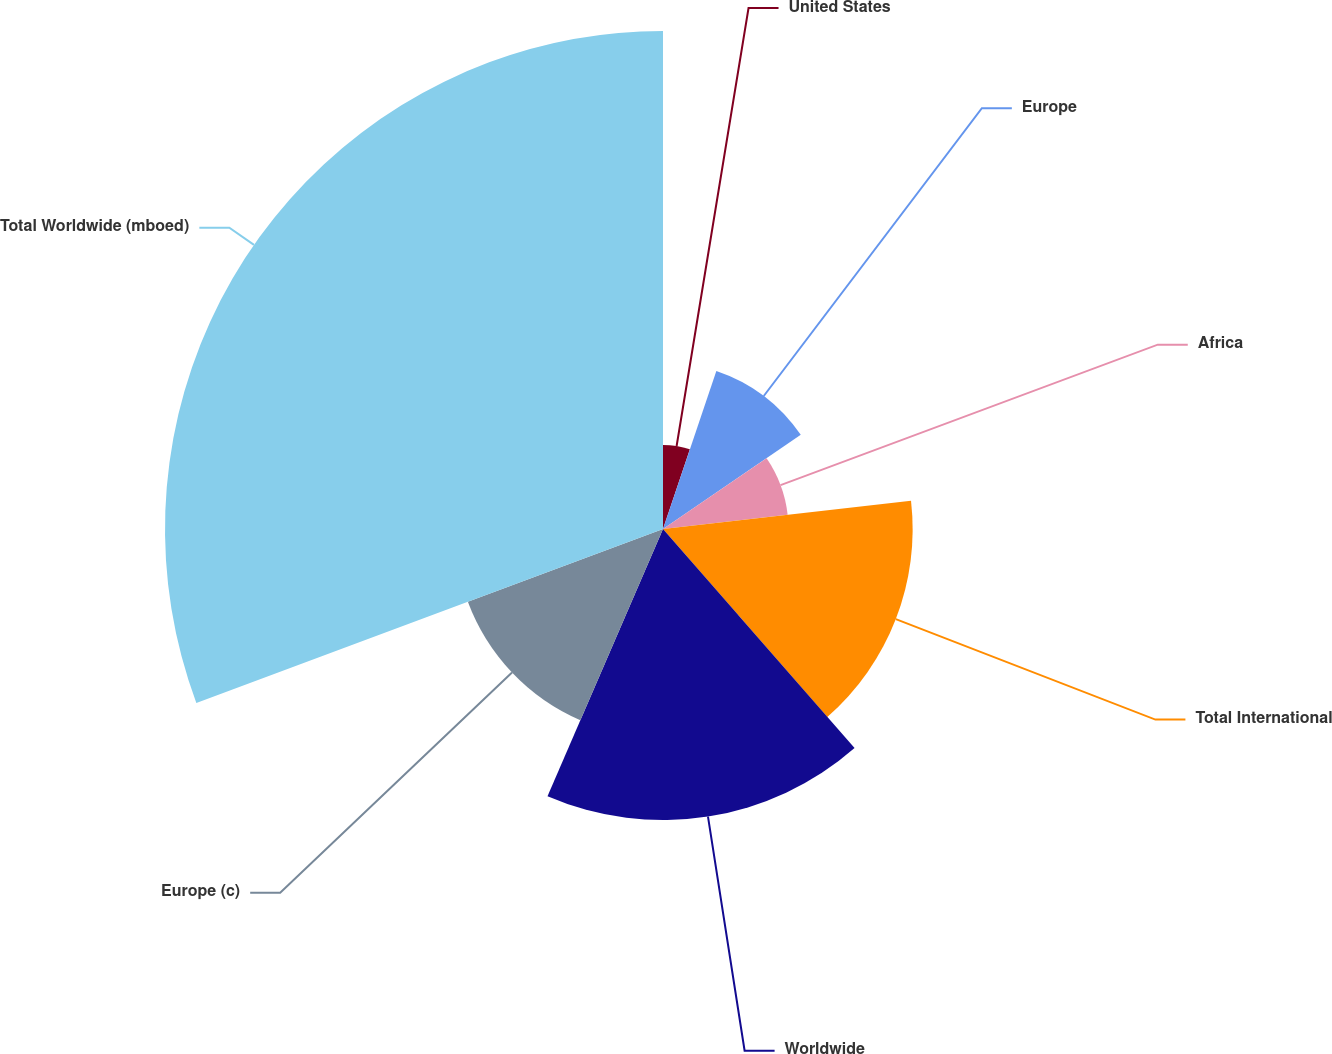<chart> <loc_0><loc_0><loc_500><loc_500><pie_chart><fcel>United States<fcel>Europe<fcel>Africa<fcel>Total International<fcel>Worldwide<fcel>Europe (c)<fcel>Total Worldwide (mboed)<nl><fcel>5.18%<fcel>10.28%<fcel>7.73%<fcel>15.38%<fcel>17.93%<fcel>12.83%<fcel>30.68%<nl></chart> 